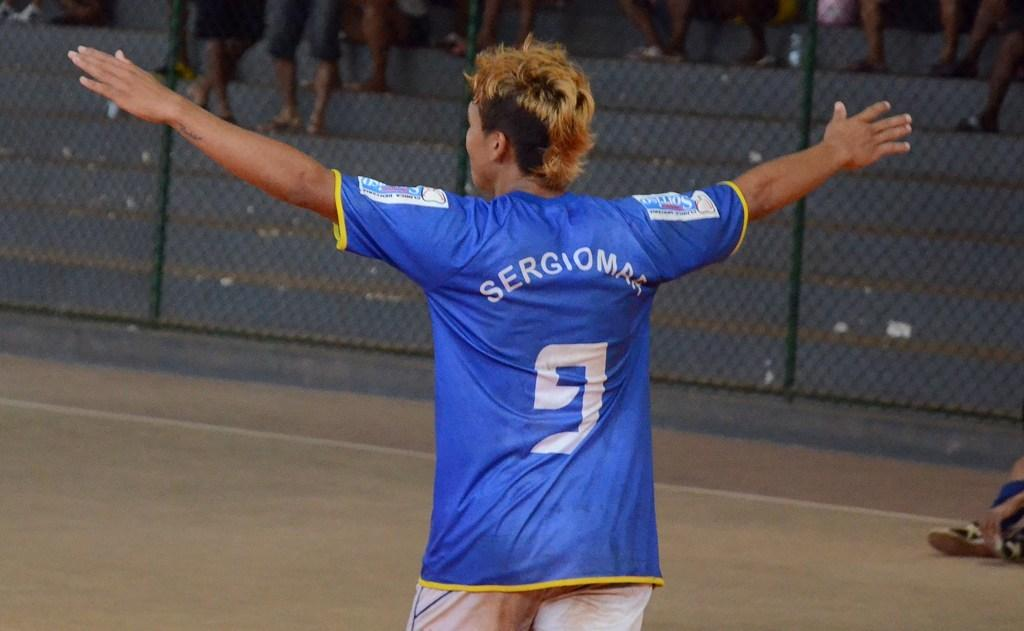<image>
Describe the image concisely. A person on a field wearing a light blue soccer jersey with number 9 on the back. 